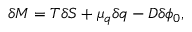<formula> <loc_0><loc_0><loc_500><loc_500>\delta M = T \delta S + \mu _ { q } \delta q - D \delta \phi _ { 0 } ,</formula> 